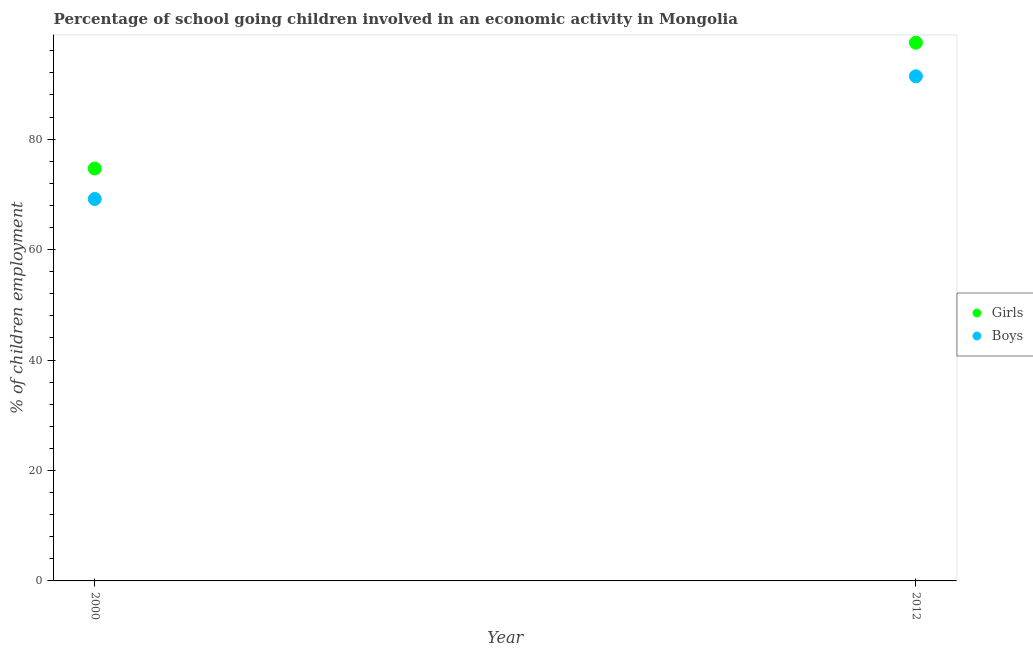What is the percentage of school going girls in 2012?
Give a very brief answer. 97.47. Across all years, what is the maximum percentage of school going boys?
Make the answer very short. 91.38. Across all years, what is the minimum percentage of school going girls?
Offer a very short reply. 74.68. In which year was the percentage of school going girls maximum?
Offer a terse response. 2012. In which year was the percentage of school going boys minimum?
Give a very brief answer. 2000. What is the total percentage of school going girls in the graph?
Offer a very short reply. 172.15. What is the difference between the percentage of school going girls in 2000 and that in 2012?
Offer a terse response. -22.79. What is the difference between the percentage of school going girls in 2012 and the percentage of school going boys in 2000?
Your response must be concise. 28.3. What is the average percentage of school going girls per year?
Offer a very short reply. 86.07. In the year 2000, what is the difference between the percentage of school going boys and percentage of school going girls?
Provide a succinct answer. -5.51. In how many years, is the percentage of school going boys greater than 60 %?
Provide a short and direct response. 2. What is the ratio of the percentage of school going boys in 2000 to that in 2012?
Your response must be concise. 0.76. Is the percentage of school going boys in 2000 less than that in 2012?
Offer a terse response. Yes. Is the percentage of school going girls strictly less than the percentage of school going boys over the years?
Make the answer very short. No. How many years are there in the graph?
Your response must be concise. 2. What is the difference between two consecutive major ticks on the Y-axis?
Your response must be concise. 20. Does the graph contain any zero values?
Ensure brevity in your answer.  No. What is the title of the graph?
Provide a succinct answer. Percentage of school going children involved in an economic activity in Mongolia. Does "Foreign liabilities" appear as one of the legend labels in the graph?
Ensure brevity in your answer.  No. What is the label or title of the Y-axis?
Ensure brevity in your answer.  % of children employment. What is the % of children employment in Girls in 2000?
Provide a short and direct response. 74.68. What is the % of children employment in Boys in 2000?
Provide a succinct answer. 69.17. What is the % of children employment of Girls in 2012?
Offer a terse response. 97.47. What is the % of children employment of Boys in 2012?
Your answer should be compact. 91.38. Across all years, what is the maximum % of children employment in Girls?
Your answer should be compact. 97.47. Across all years, what is the maximum % of children employment in Boys?
Your response must be concise. 91.38. Across all years, what is the minimum % of children employment of Girls?
Make the answer very short. 74.68. Across all years, what is the minimum % of children employment in Boys?
Offer a very short reply. 69.17. What is the total % of children employment in Girls in the graph?
Offer a very short reply. 172.15. What is the total % of children employment in Boys in the graph?
Give a very brief answer. 160.55. What is the difference between the % of children employment of Girls in 2000 and that in 2012?
Ensure brevity in your answer.  -22.79. What is the difference between the % of children employment of Boys in 2000 and that in 2012?
Give a very brief answer. -22.21. What is the difference between the % of children employment in Girls in 2000 and the % of children employment in Boys in 2012?
Your answer should be very brief. -16.7. What is the average % of children employment of Girls per year?
Provide a succinct answer. 86.08. What is the average % of children employment in Boys per year?
Offer a very short reply. 80.27. In the year 2000, what is the difference between the % of children employment of Girls and % of children employment of Boys?
Offer a terse response. 5.51. In the year 2012, what is the difference between the % of children employment of Girls and % of children employment of Boys?
Your response must be concise. 6.09. What is the ratio of the % of children employment of Girls in 2000 to that in 2012?
Offer a very short reply. 0.77. What is the ratio of the % of children employment in Boys in 2000 to that in 2012?
Your answer should be compact. 0.76. What is the difference between the highest and the second highest % of children employment of Girls?
Ensure brevity in your answer.  22.79. What is the difference between the highest and the second highest % of children employment of Boys?
Your answer should be very brief. 22.21. What is the difference between the highest and the lowest % of children employment in Girls?
Offer a terse response. 22.79. What is the difference between the highest and the lowest % of children employment of Boys?
Offer a terse response. 22.21. 